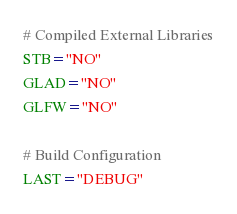Convert code to text. <code><loc_0><loc_0><loc_500><loc_500><_Bash_># Compiled External Libraries
STB="NO"
GLAD="NO"
GLFW="NO"

# Build Configuration
LAST="DEBUG"
</code> 